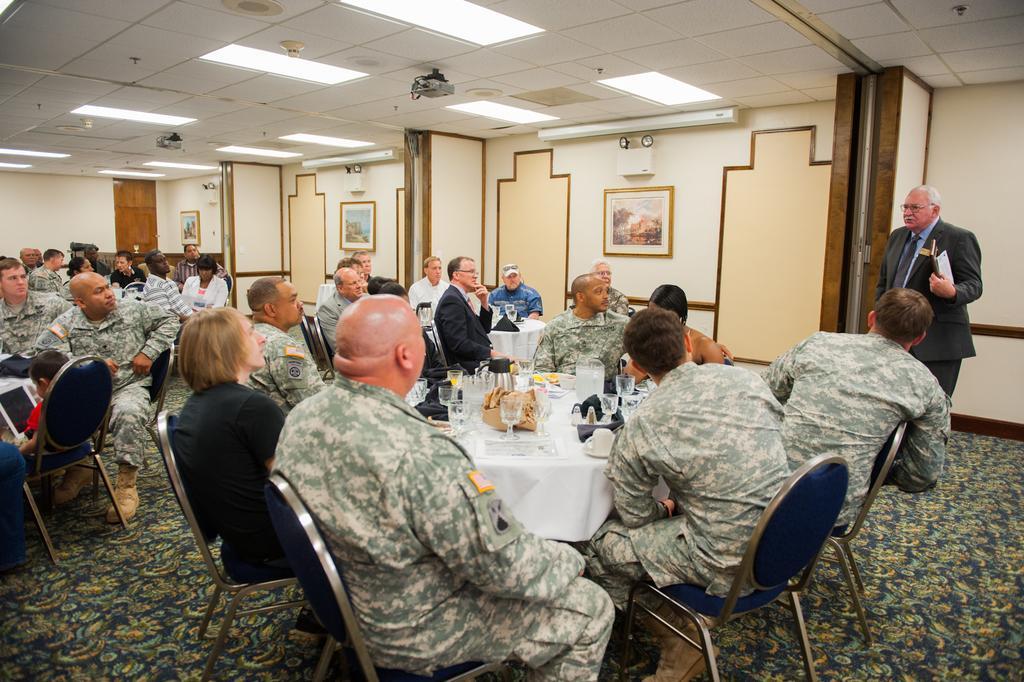Could you give a brief overview of what you see in this image? There are people sitting on chairs and this man standing and holding an object. We can see glasses and objects on tables. In the background we can see frames on the wall. At the top we can see lights. 